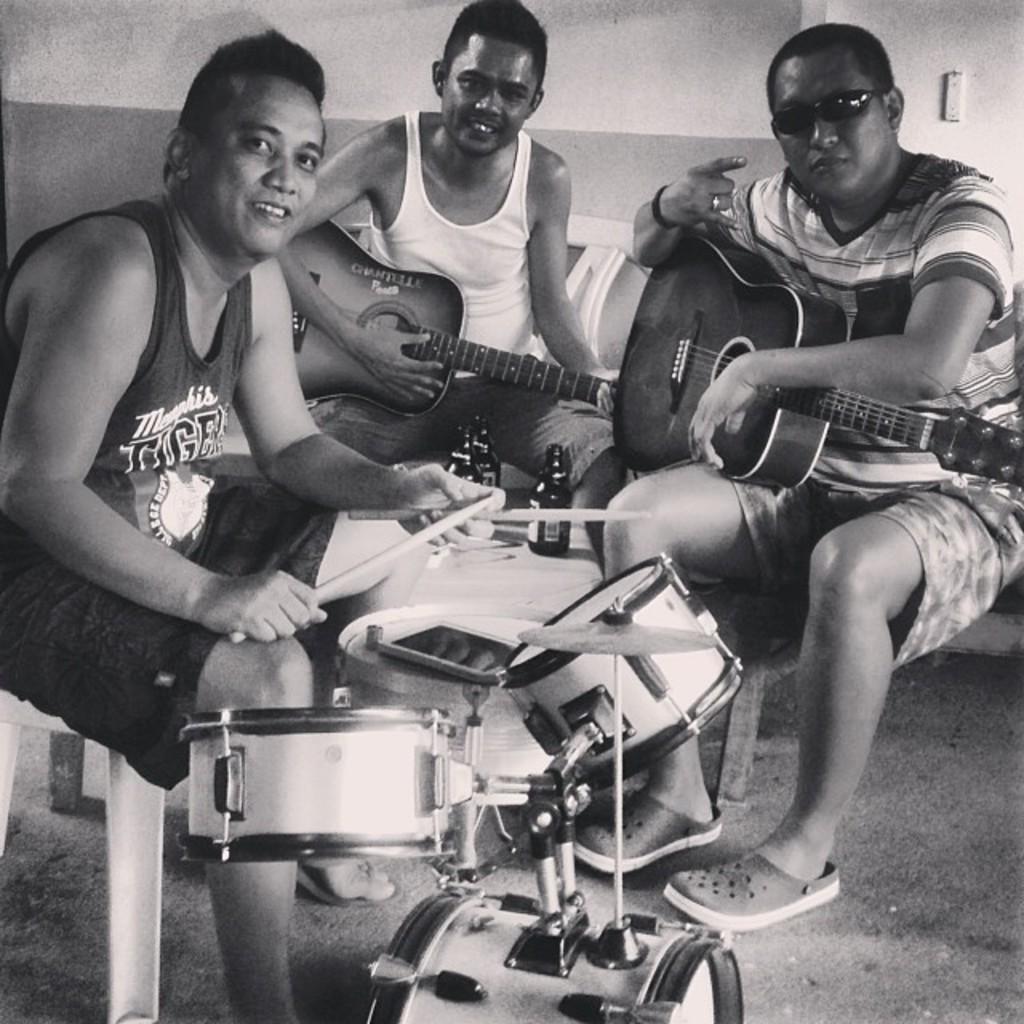In one or two sentences, can you explain what this image depicts? This image is clicked in a room. There are three persons in this image. To the left, the man is playing drums. To the right, the man is holding guitar. In the middle , the man is playing guitar. In the background, there is a wall. 